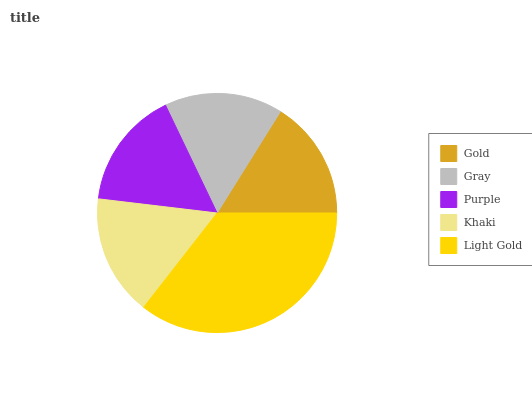Is Gray the minimum?
Answer yes or no. Yes. Is Light Gold the maximum?
Answer yes or no. Yes. Is Purple the minimum?
Answer yes or no. No. Is Purple the maximum?
Answer yes or no. No. Is Purple greater than Gray?
Answer yes or no. Yes. Is Gray less than Purple?
Answer yes or no. Yes. Is Gray greater than Purple?
Answer yes or no. No. Is Purple less than Gray?
Answer yes or no. No. Is Gold the high median?
Answer yes or no. Yes. Is Gold the low median?
Answer yes or no. Yes. Is Purple the high median?
Answer yes or no. No. Is Khaki the low median?
Answer yes or no. No. 